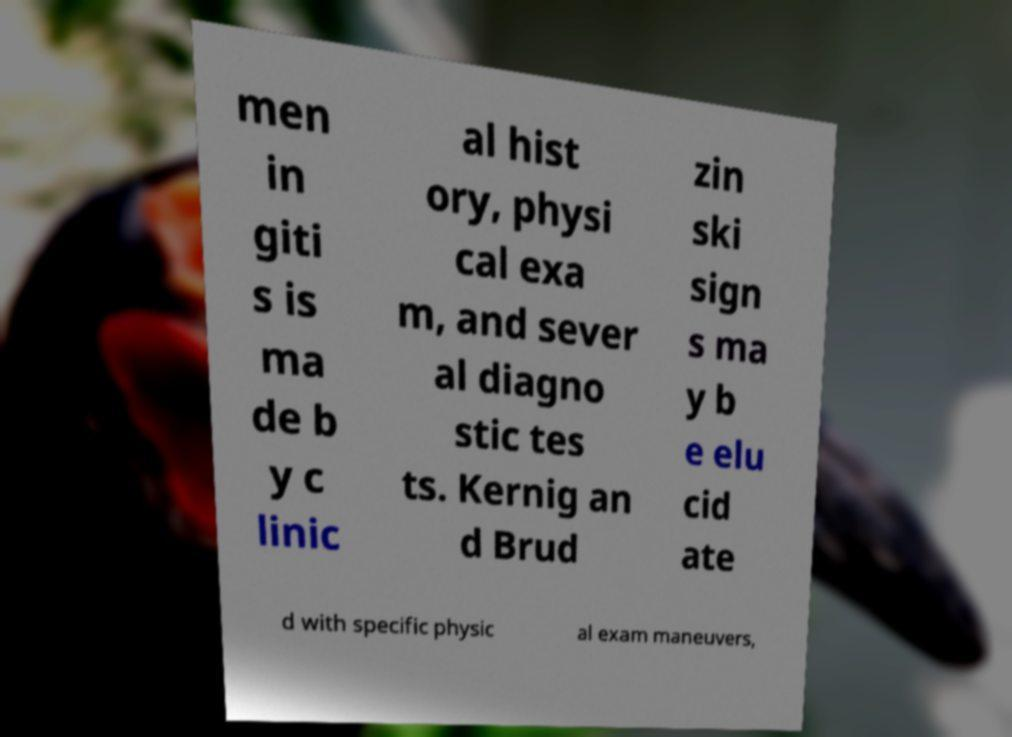Could you extract and type out the text from this image? men in giti s is ma de b y c linic al hist ory, physi cal exa m, and sever al diagno stic tes ts. Kernig an d Brud zin ski sign s ma y b e elu cid ate d with specific physic al exam maneuvers, 